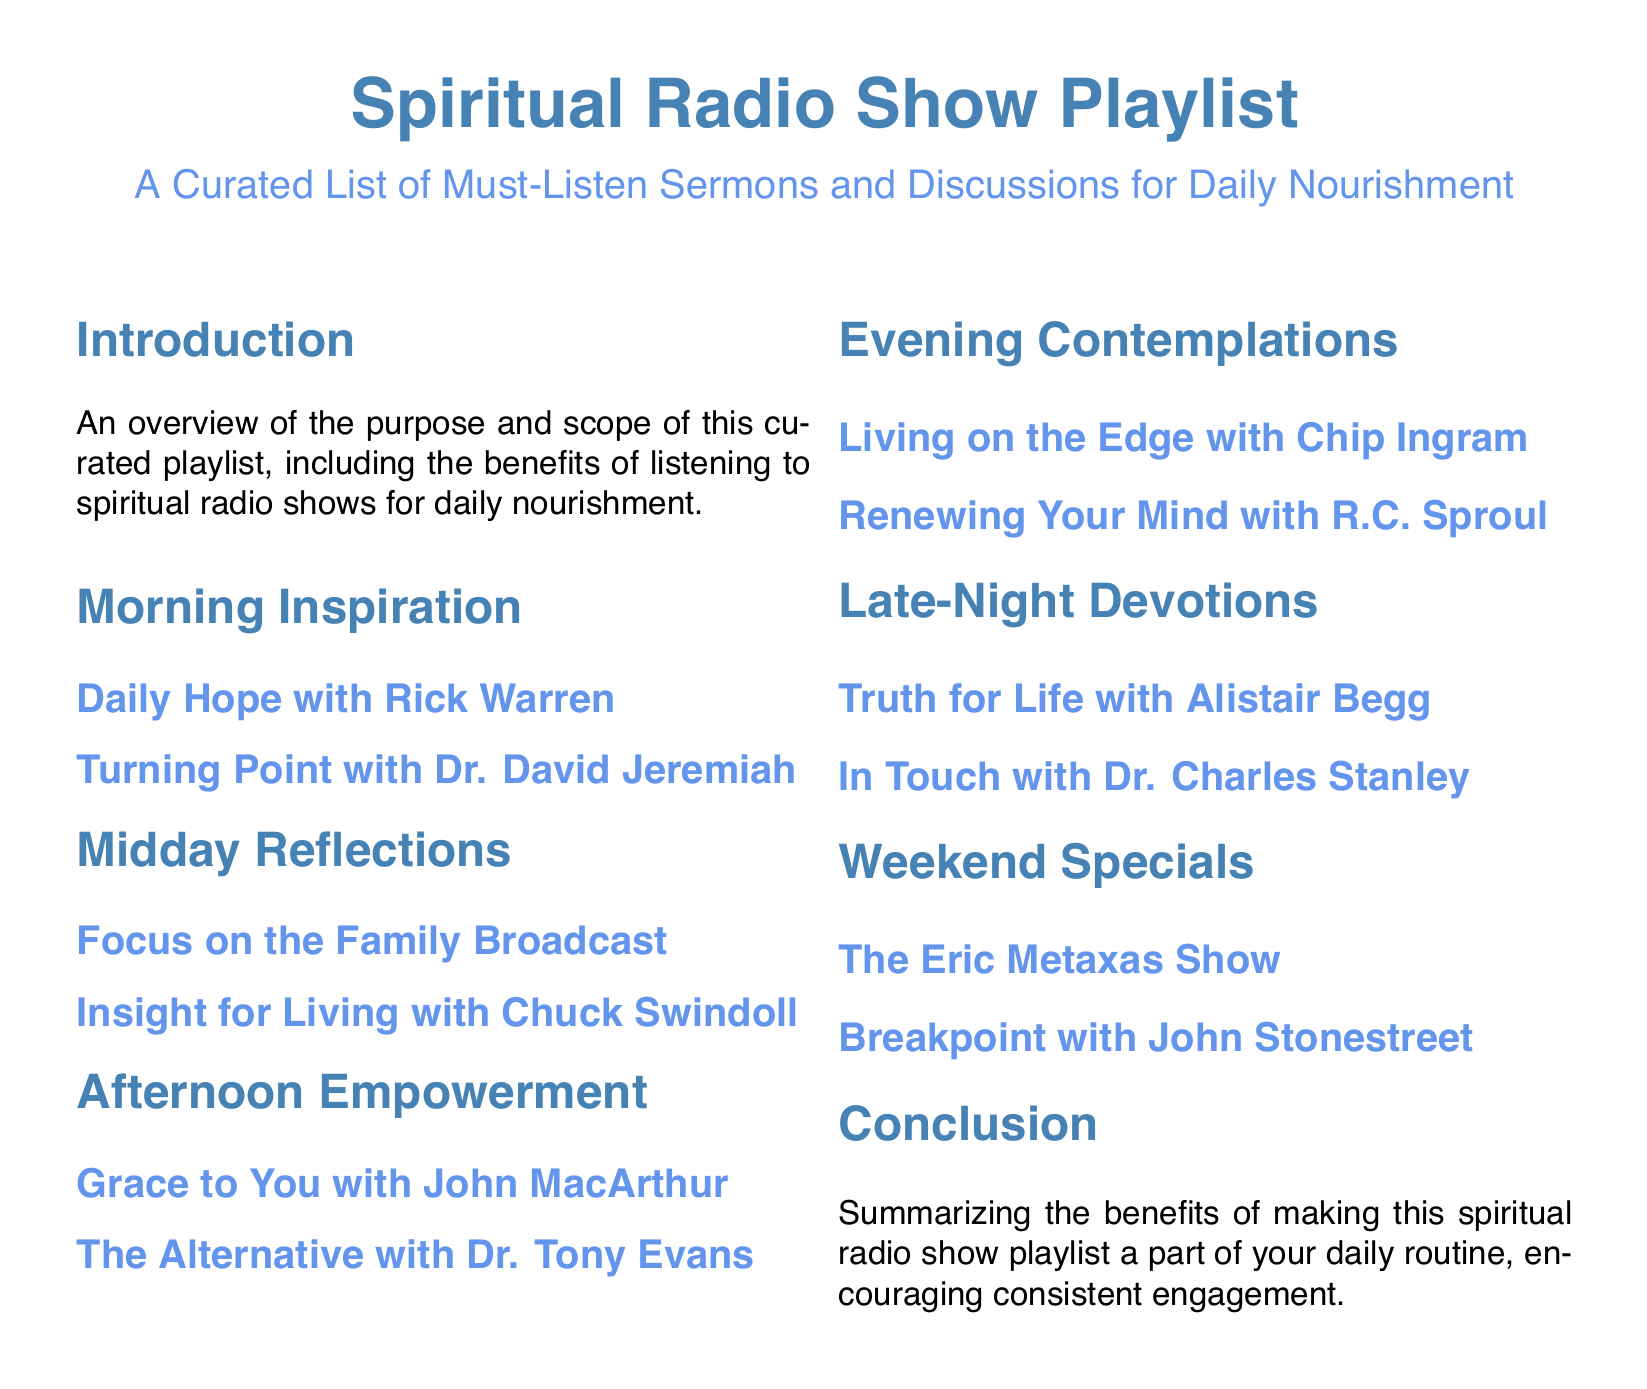What is the title of the document? The title is prominently displayed at the beginning of the document and clearly states what the content is about.
Answer: Spiritual Radio Show Playlist Who is the host of the "Daily Hope" program? The document mentions the host of the "Daily Hope" program in the entry under Morning Inspiration.
Answer: Rick Warren What is the focus of the "Afternoon Empowerment" section? The section lists various programs aimed at uplifting and empowering listeners in the afternoon.
Answer: Empowerment Which program is featured in the "Weekend Specials"? The section provides two specific programs that are curated for weekend listening.
Answer: The Eric Metaxas Show How many sections are there in total? The document outlines different parts dedicated to various times of day, which can be counted.
Answer: Seven What is the goal of the playlist according to the conclusion? The conclusion summarizes the overall intent of incorporating this playlist into a daily routine.
Answer: Encouraging consistent engagement Who is the host of "Renewing Your Mind"? This information is included in the Evening Contemplations section, where the host of the program is noted.
Answer: R.C. Sproul What type of shows are included in the "Late-Night Devotions" section? This section highlights specific programs designed for night-time spiritual reflection.
Answer: Devotions Where can "Insight for Living" be found in the document? The document indicates the specific time of day when this show is scheduled, located in midday reflections.
Answer: Midday Reflections 